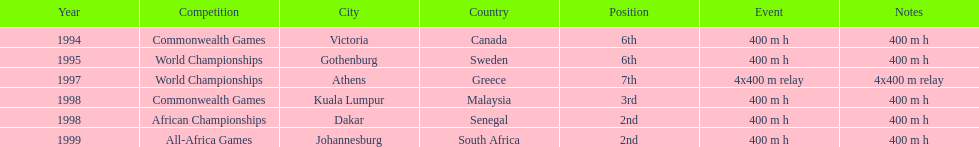Where was the next venue after athens, greece? Kuala Lumpur, Malaysia. 